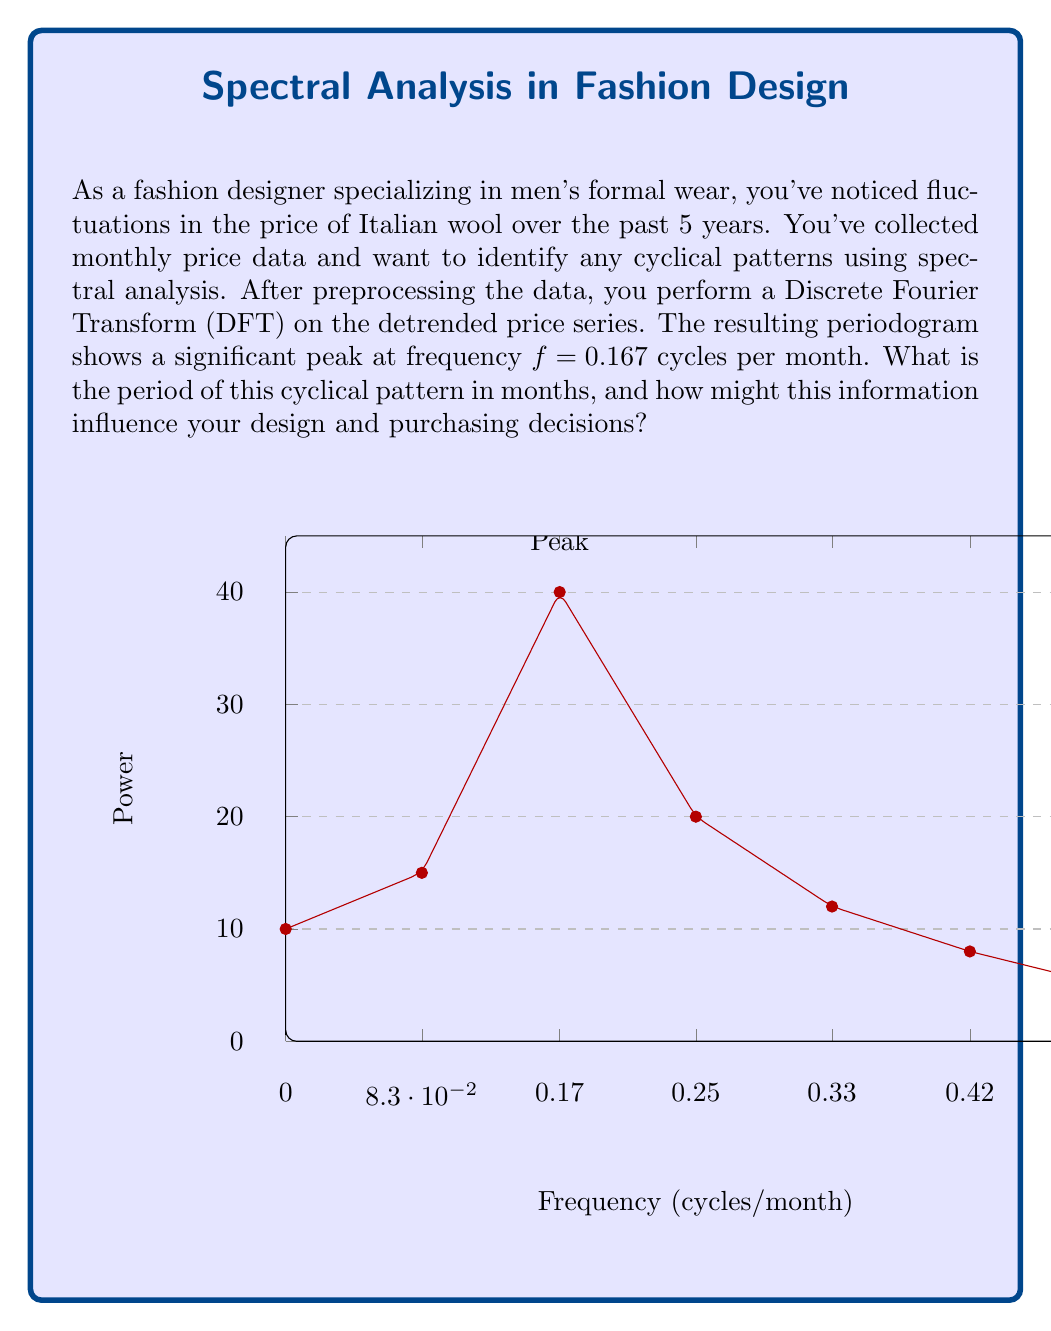Provide a solution to this math problem. To solve this problem, we'll follow these steps:

1) Recall that frequency (f) and period (T) are inversely related:

   $$T = \frac{1}{f}$$

2) We're given the frequency $f = 0.167$ cycles per month. Let's substitute this into our equation:

   $$T = \frac{1}{0.167}$$

3) Calculate the result:

   $$T \approx 5.988 \text{ months}$$

4) Round to the nearest whole month:

   $$T \approx 6 \text{ months}$$

This means the cyclical pattern repeats approximately every 6 months.

Interpretation for a fashion designer:
- This semi-annual cycle could align with seasonal changes in fashion (spring/summer and fall/winter collections).
- You might plan your purchasing and design cycles around this 6-month pattern to optimize costs.
- Consider creating designs that can be easily adapted or transitioned between seasons to take advantage of this price cycle.
- You could time your bulk purchases of Italian wool to coincide with the lower points in this price cycle, potentially every 6 months.
Answer: 6 months 